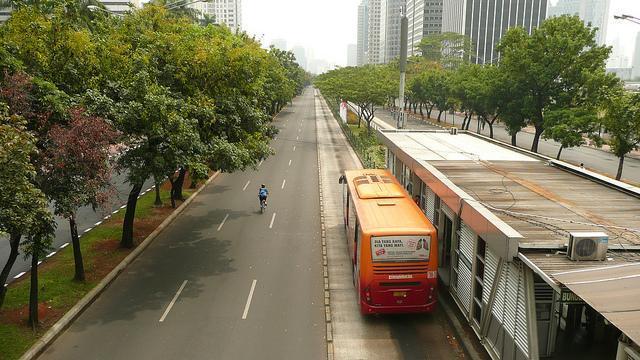How many bicycles are on the road?
Give a very brief answer. 1. 